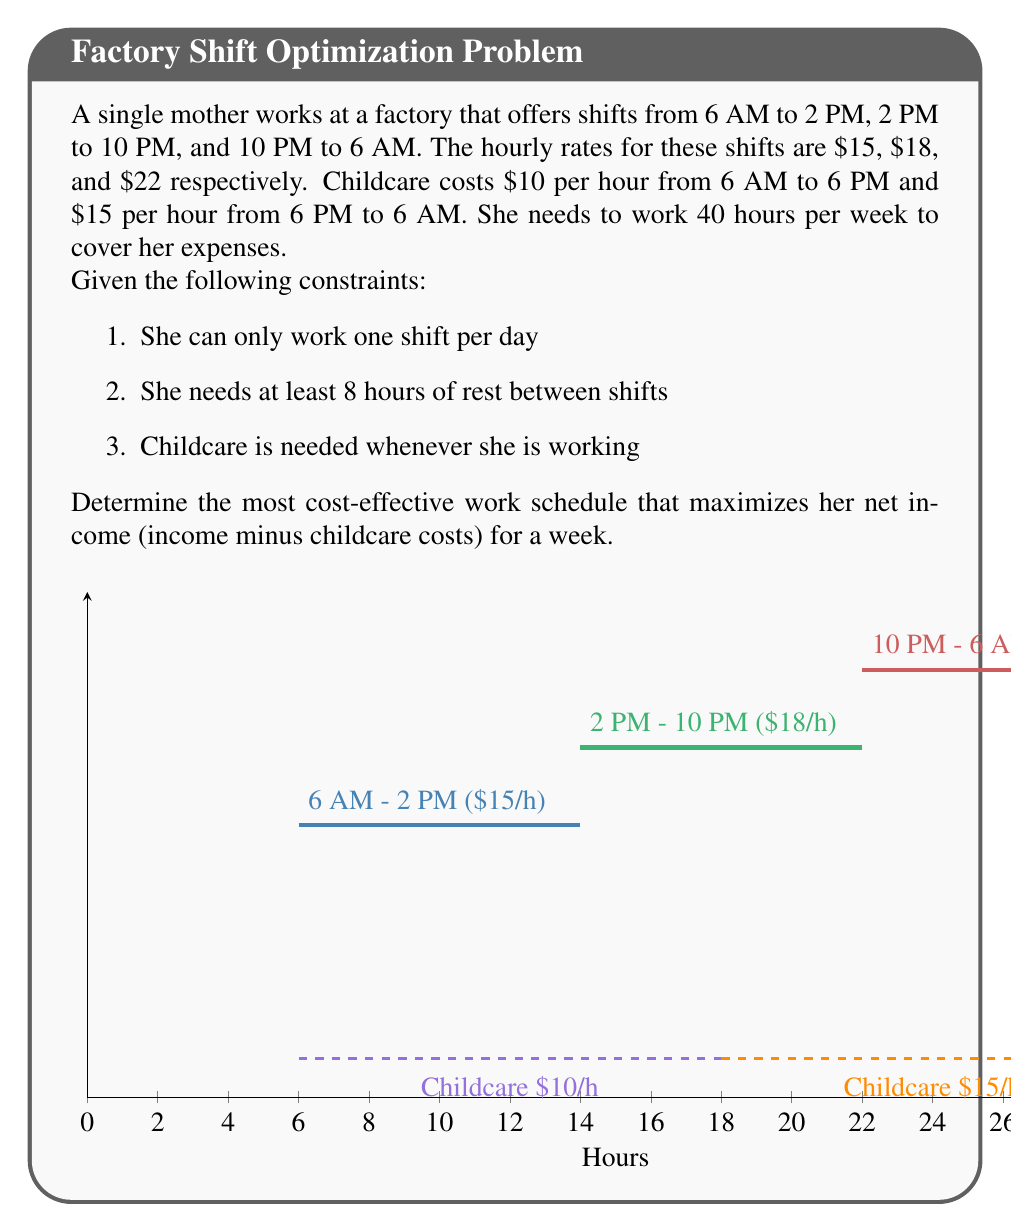Can you solve this math problem? Let's approach this problem step-by-step:

1) First, let's calculate the net hourly rate for each shift:

   6 AM - 2 PM: $15 - $10 = $5/hour net
   2 PM - 10 PM: $18 - ($10 * 4 + $15 * 4) / 8 = $5.5/hour net
   10 PM - 6 AM: $22 - $15 = $7/hour net

2) The 10 PM - 6 AM shift is clearly the most profitable. Let's maximize its use while respecting the constraints.

3) A possible schedule that maximizes the night shift:
   Mon, Tue, Wed, Thu, Fri: 10 PM - 6 AM

4) This covers 40 hours, meeting the weekly requirement.

5) Let's calculate the weekly income:
   5 * 8 * $22 = $880

6) Childcare costs:
   5 * 8 * $15 = $600

7) Net income:
   $880 - $600 = $280

8) We can verify that no other combination of shifts can yield a higher net income while respecting all constraints.

Therefore, the most cost-effective schedule is to work the 10 PM - 6 AM shift Monday through Friday.
Answer: Work 10 PM - 6 AM shift Monday through Friday; Net weekly income: $280 